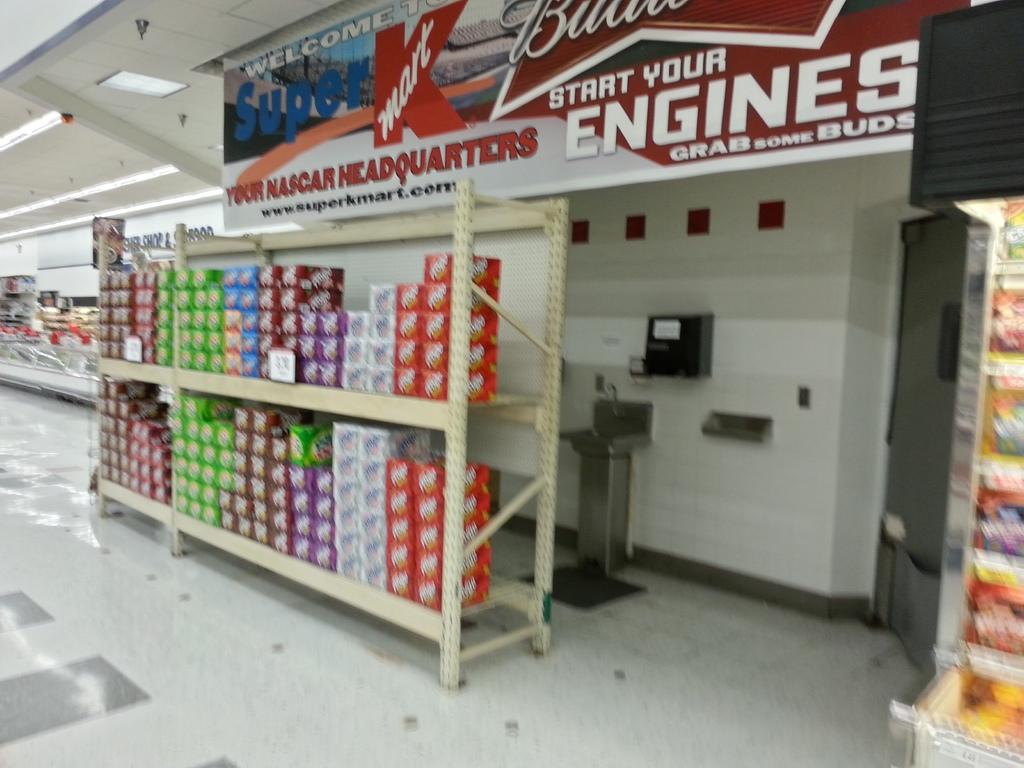<image>
Share a concise interpretation of the image provided. A kmart banner that says your Nascar headquarters is about 12pk cartons of various sodas. 